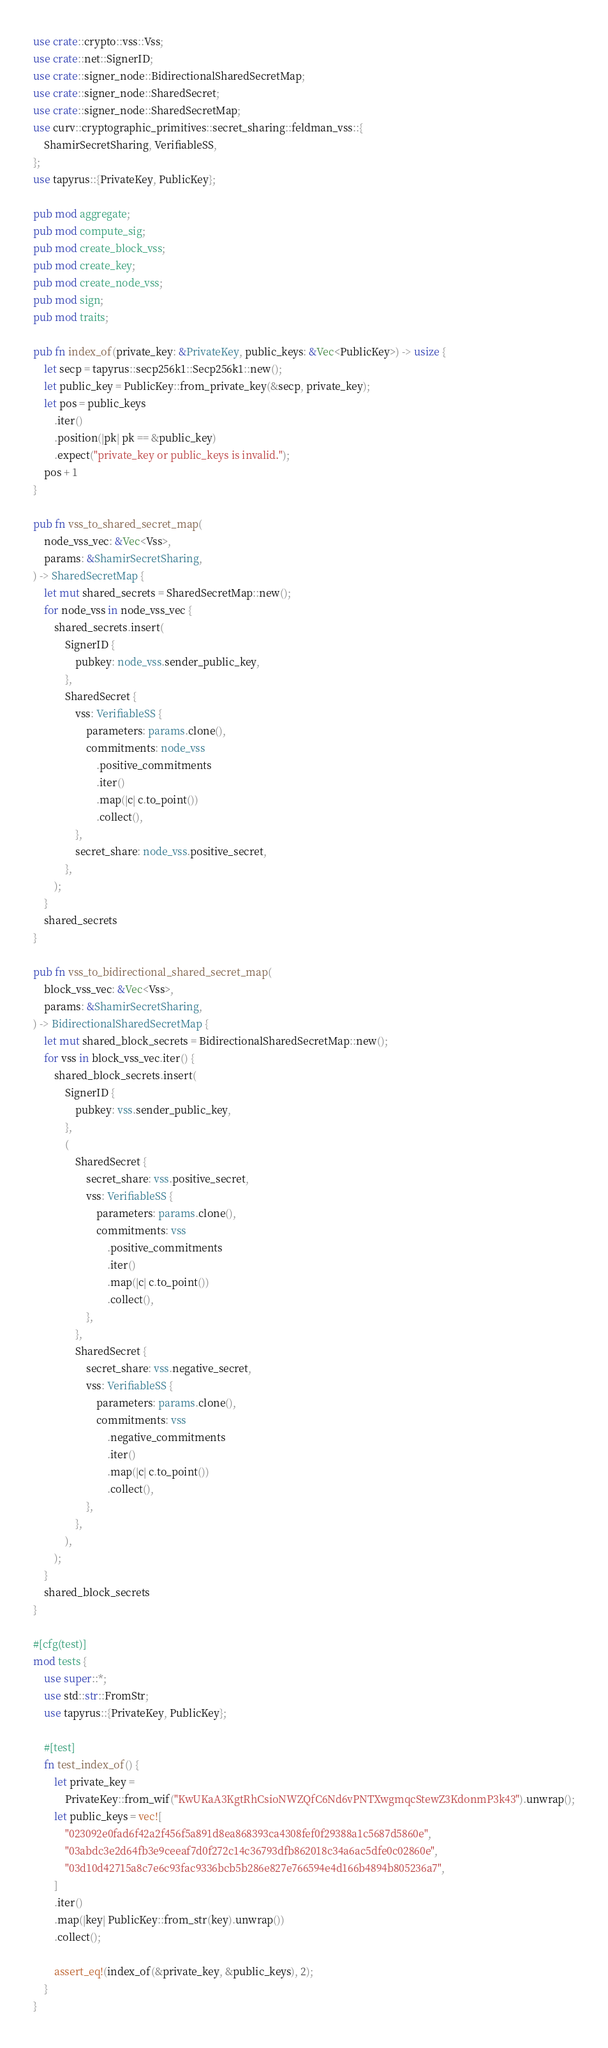Convert code to text. <code><loc_0><loc_0><loc_500><loc_500><_Rust_>use crate::crypto::vss::Vss;
use crate::net::SignerID;
use crate::signer_node::BidirectionalSharedSecretMap;
use crate::signer_node::SharedSecret;
use crate::signer_node::SharedSecretMap;
use curv::cryptographic_primitives::secret_sharing::feldman_vss::{
    ShamirSecretSharing, VerifiableSS,
};
use tapyrus::{PrivateKey, PublicKey};

pub mod aggregate;
pub mod compute_sig;
pub mod create_block_vss;
pub mod create_key;
pub mod create_node_vss;
pub mod sign;
pub mod traits;

pub fn index_of(private_key: &PrivateKey, public_keys: &Vec<PublicKey>) -> usize {
    let secp = tapyrus::secp256k1::Secp256k1::new();
    let public_key = PublicKey::from_private_key(&secp, private_key);
    let pos = public_keys
        .iter()
        .position(|pk| pk == &public_key)
        .expect("private_key or public_keys is invalid.");
    pos + 1
}

pub fn vss_to_shared_secret_map(
    node_vss_vec: &Vec<Vss>,
    params: &ShamirSecretSharing,
) -> SharedSecretMap {
    let mut shared_secrets = SharedSecretMap::new();
    for node_vss in node_vss_vec {
        shared_secrets.insert(
            SignerID {
                pubkey: node_vss.sender_public_key,
            },
            SharedSecret {
                vss: VerifiableSS {
                    parameters: params.clone(),
                    commitments: node_vss
                        .positive_commitments
                        .iter()
                        .map(|c| c.to_point())
                        .collect(),
                },
                secret_share: node_vss.positive_secret,
            },
        );
    }
    shared_secrets
}

pub fn vss_to_bidirectional_shared_secret_map(
    block_vss_vec: &Vec<Vss>,
    params: &ShamirSecretSharing,
) -> BidirectionalSharedSecretMap {
    let mut shared_block_secrets = BidirectionalSharedSecretMap::new();
    for vss in block_vss_vec.iter() {
        shared_block_secrets.insert(
            SignerID {
                pubkey: vss.sender_public_key,
            },
            (
                SharedSecret {
                    secret_share: vss.positive_secret,
                    vss: VerifiableSS {
                        parameters: params.clone(),
                        commitments: vss
                            .positive_commitments
                            .iter()
                            .map(|c| c.to_point())
                            .collect(),
                    },
                },
                SharedSecret {
                    secret_share: vss.negative_secret,
                    vss: VerifiableSS {
                        parameters: params.clone(),
                        commitments: vss
                            .negative_commitments
                            .iter()
                            .map(|c| c.to_point())
                            .collect(),
                    },
                },
            ),
        );
    }
    shared_block_secrets
}

#[cfg(test)]
mod tests {
    use super::*;
    use std::str::FromStr;
    use tapyrus::{PrivateKey, PublicKey};

    #[test]
    fn test_index_of() {
        let private_key =
            PrivateKey::from_wif("KwUKaA3KgtRhCsioNWZQfC6Nd6vPNTXwgmqcStewZ3KdonmP3k43").unwrap();
        let public_keys = vec![
            "023092e0fad6f42a2f456f5a891d8ea868393ca4308fef0f29388a1c5687d5860e",
            "03abdc3e2d64fb3e9ceeaf7d0f272c14c36793dfb862018c34a6ac5dfe0c02860e",
            "03d10d42715a8c7e6c93fac9336bcb5b286e827e766594e4d166b4894b805236a7",
        ]
        .iter()
        .map(|key| PublicKey::from_str(key).unwrap())
        .collect();

        assert_eq!(index_of(&private_key, &public_keys), 2);
    }
}
</code> 